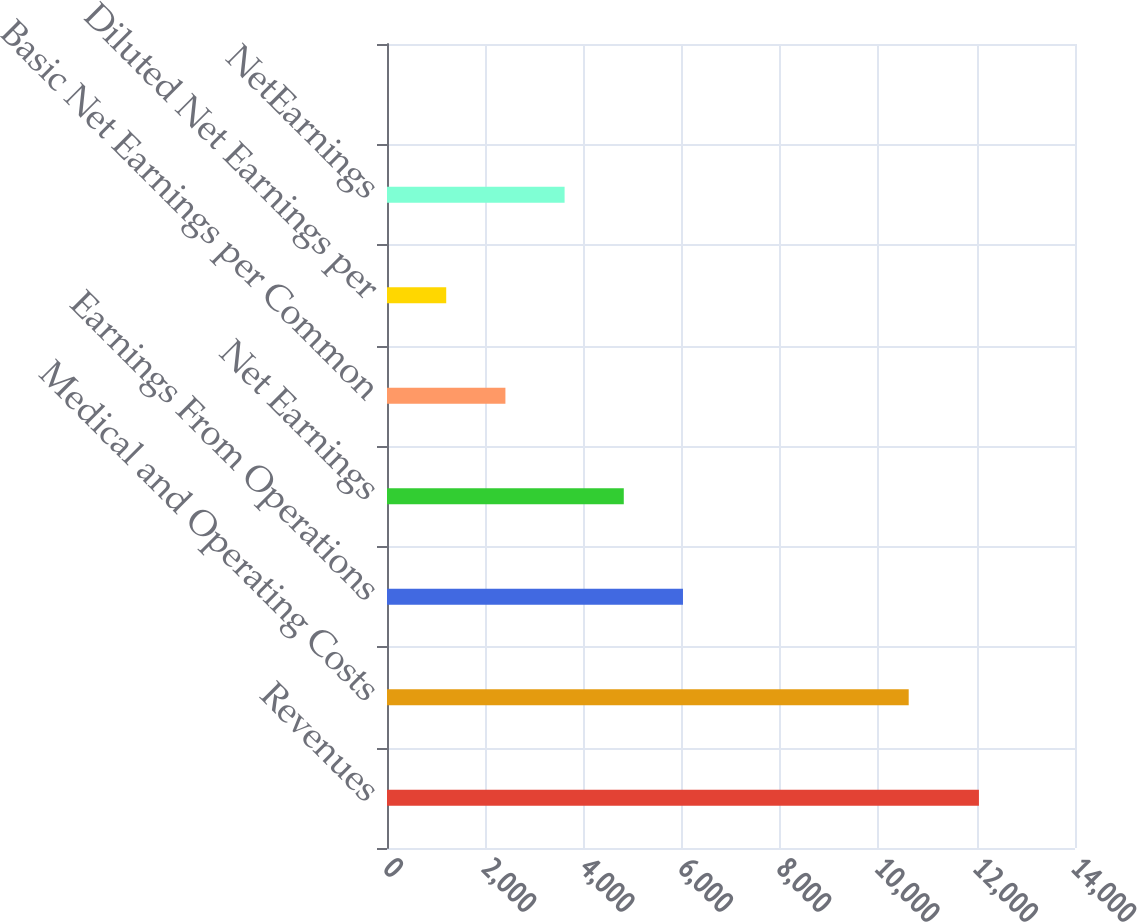Convert chart. <chart><loc_0><loc_0><loc_500><loc_500><bar_chart><fcel>Revenues<fcel>Medical and Operating Costs<fcel>Earnings From Operations<fcel>Net Earnings<fcel>Basic Net Earnings per Common<fcel>Diluted Net Earnings per<fcel>NetEarnings<fcel>Unnamed: 7<nl><fcel>12045<fcel>10616<fcel>6022.79<fcel>4818.34<fcel>2409.44<fcel>1204.99<fcel>3613.89<fcel>0.54<nl></chart> 